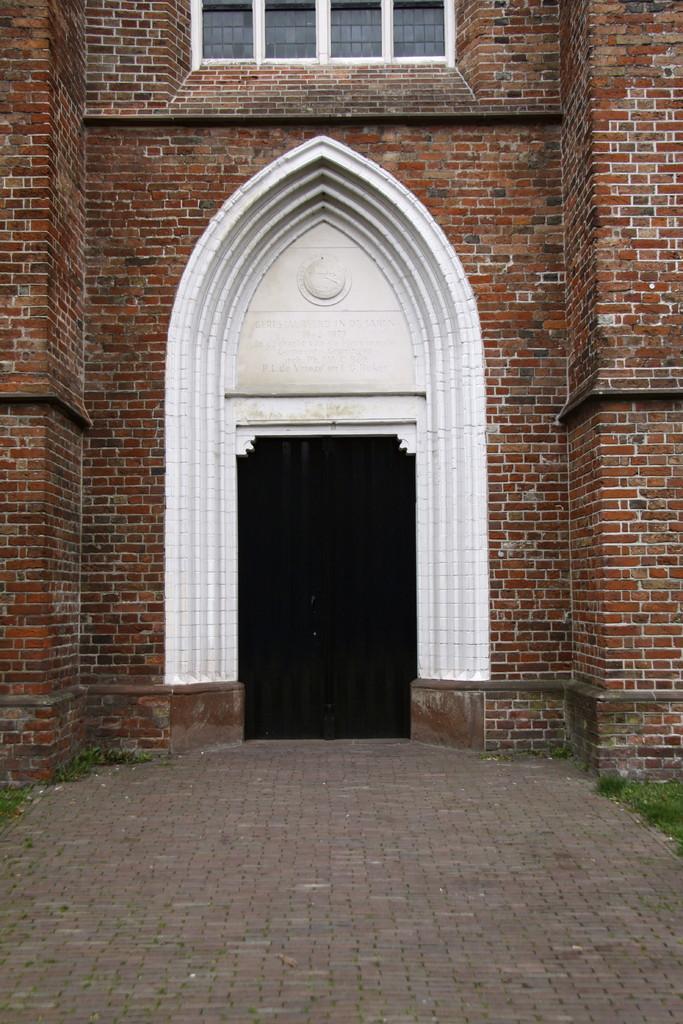Please provide a concise description of this image. In this image, we can see the wall with a few windows. We can also see an arch. We can see the ground. We can also see some grass. 